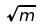<formula> <loc_0><loc_0><loc_500><loc_500>\sqrt { m }</formula> 